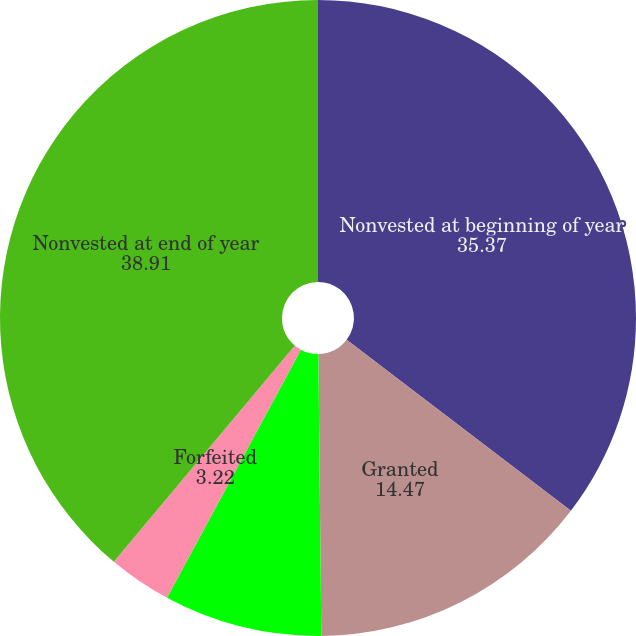<chart> <loc_0><loc_0><loc_500><loc_500><pie_chart><fcel>Nonvested at beginning of year<fcel>Granted<fcel>Vested<fcel>Forfeited<fcel>Nonvested at end of year<nl><fcel>35.37%<fcel>14.47%<fcel>8.04%<fcel>3.22%<fcel>38.91%<nl></chart> 